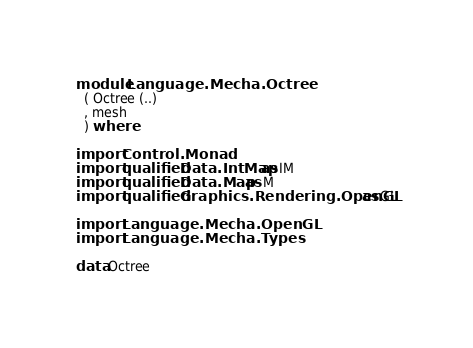Convert code to text. <code><loc_0><loc_0><loc_500><loc_500><_Haskell_>module Language.Mecha.Octree
  ( Octree (..)
  , mesh
  ) where

import Control.Monad
import qualified Data.IntMap as IM
import qualified Data.Map as M
import qualified Graphics.Rendering.OpenGL as GL

import Language.Mecha.OpenGL
import Language.Mecha.Types

data Octree</code> 